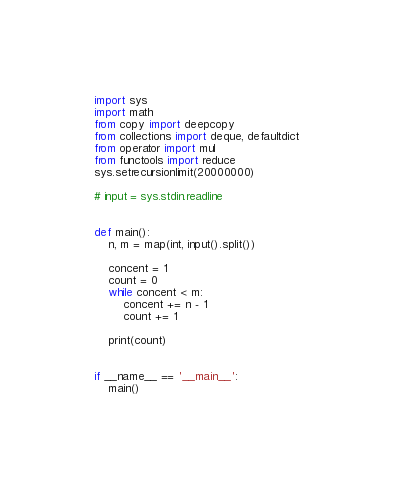<code> <loc_0><loc_0><loc_500><loc_500><_Python_>import sys
import math
from copy import deepcopy
from collections import deque, defaultdict
from operator import mul
from functools import reduce
sys.setrecursionlimit(20000000)

# input = sys.stdin.readline


def main():
    n, m = map(int, input().split())

    concent = 1
    count = 0
    while concent < m:
        concent += n - 1
        count += 1

    print(count)


if __name__ == '__main__':
    main()</code> 